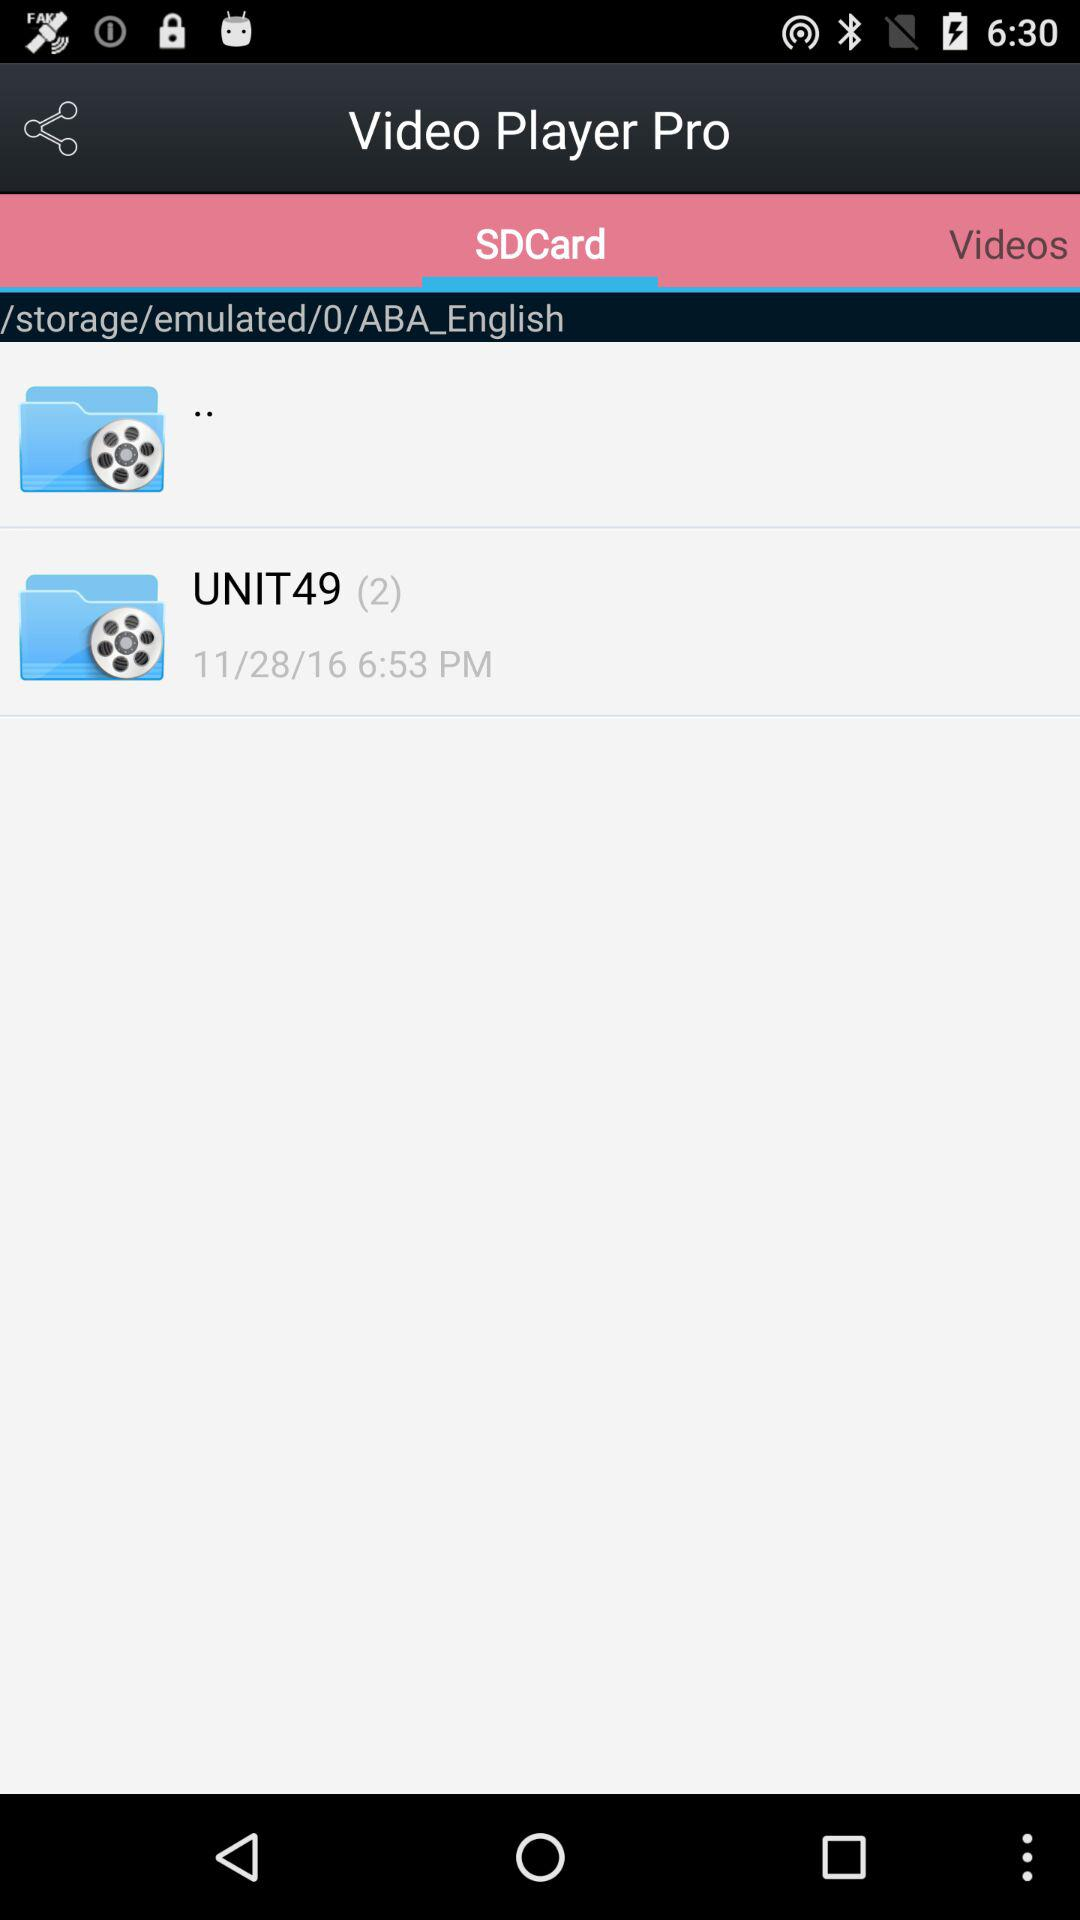What is the given time? The given time is 6:53 PM. 